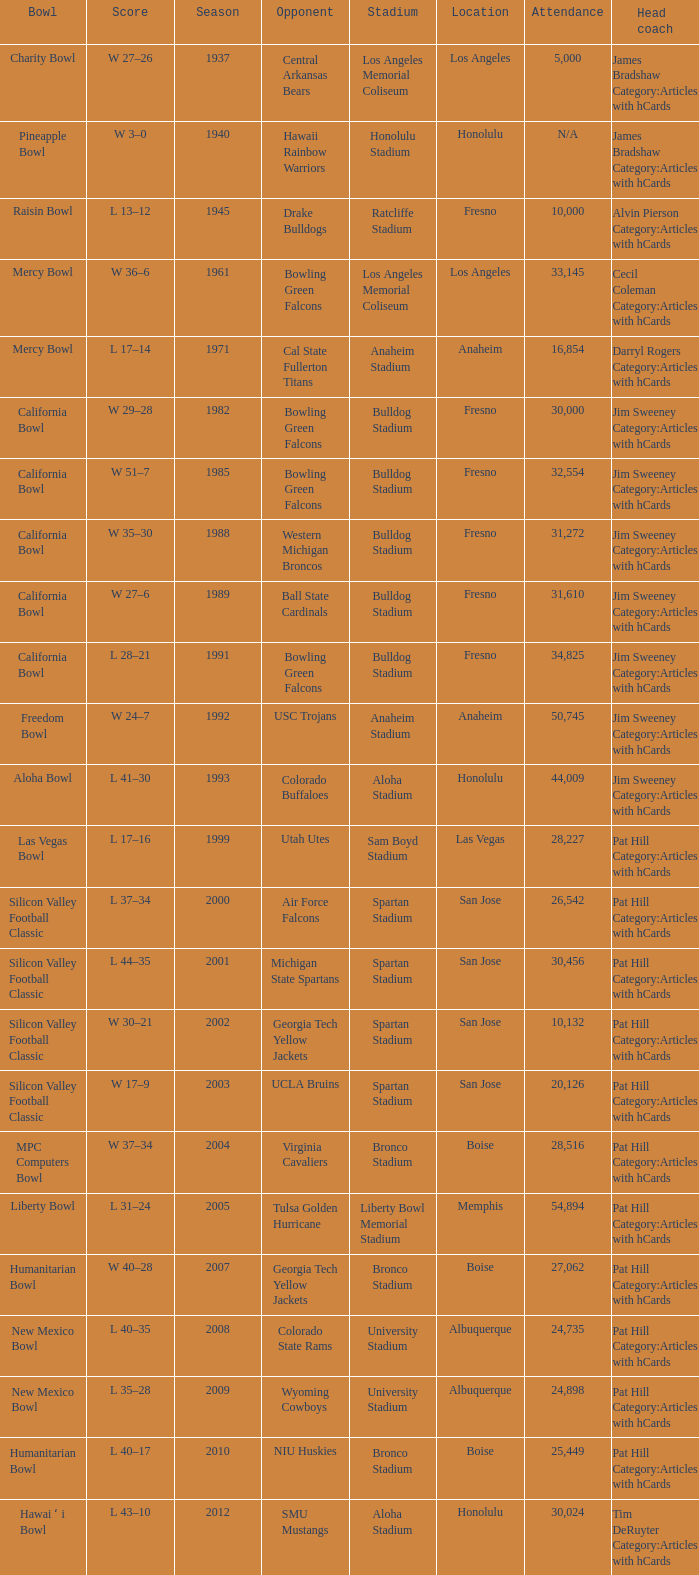Where was the california bowl held with 30,000 spectators? Fresno. 